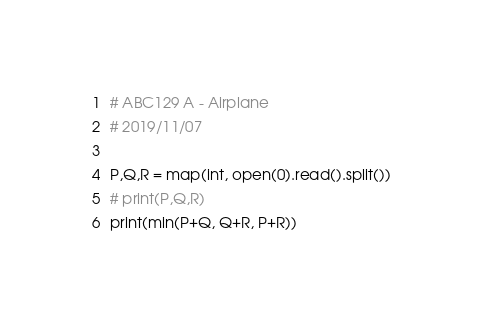<code> <loc_0><loc_0><loc_500><loc_500><_Python_># ABC129 A - Airplane
# 2019/11/07

P,Q,R = map(int, open(0).read().split())
# print(P,Q,R)
print(min(P+Q, Q+R, P+R))</code> 